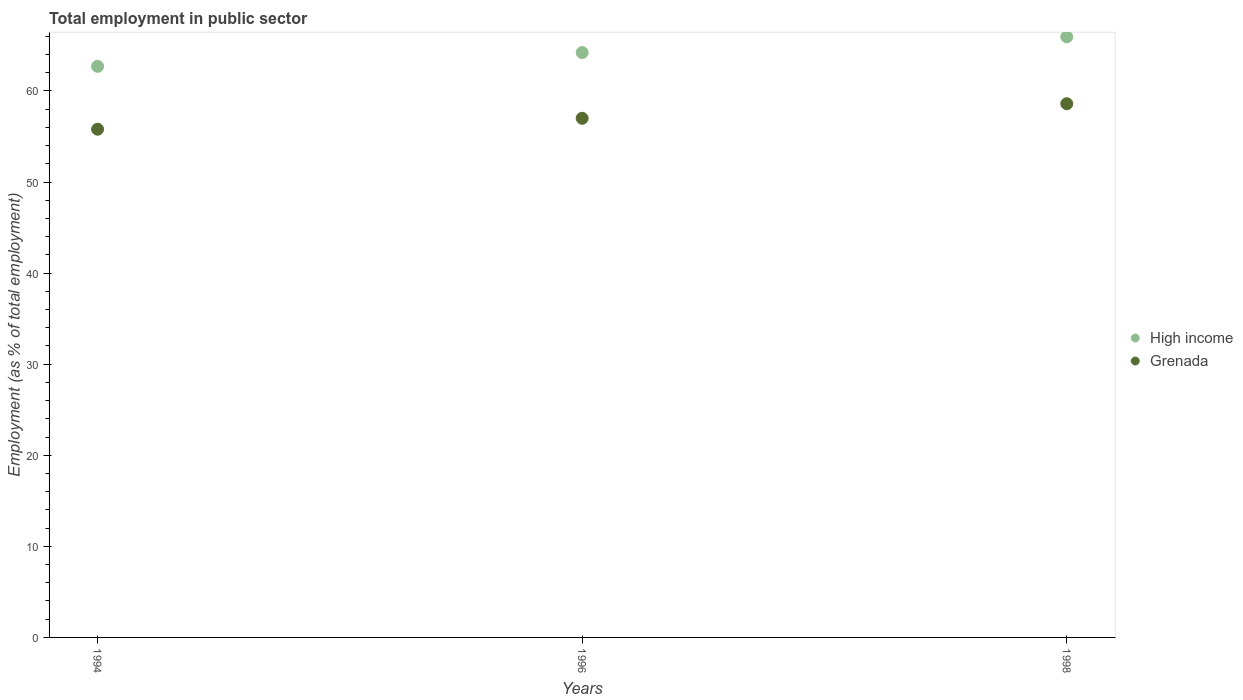How many different coloured dotlines are there?
Provide a short and direct response. 2. Is the number of dotlines equal to the number of legend labels?
Your response must be concise. Yes. What is the employment in public sector in High income in 1996?
Give a very brief answer. 64.22. Across all years, what is the maximum employment in public sector in Grenada?
Give a very brief answer. 58.6. Across all years, what is the minimum employment in public sector in High income?
Provide a succinct answer. 62.71. In which year was the employment in public sector in High income maximum?
Keep it short and to the point. 1998. What is the total employment in public sector in High income in the graph?
Make the answer very short. 192.86. What is the difference between the employment in public sector in High income in 1996 and that in 1998?
Provide a succinct answer. -1.72. What is the difference between the employment in public sector in Grenada in 1998 and the employment in public sector in High income in 1996?
Provide a short and direct response. -5.62. What is the average employment in public sector in Grenada per year?
Your answer should be compact. 57.13. In the year 1998, what is the difference between the employment in public sector in Grenada and employment in public sector in High income?
Offer a very short reply. -7.34. What is the ratio of the employment in public sector in High income in 1994 to that in 1996?
Give a very brief answer. 0.98. Is the employment in public sector in Grenada in 1994 less than that in 1996?
Your response must be concise. Yes. Is the difference between the employment in public sector in Grenada in 1994 and 1996 greater than the difference between the employment in public sector in High income in 1994 and 1996?
Give a very brief answer. Yes. What is the difference between the highest and the second highest employment in public sector in High income?
Give a very brief answer. 1.72. What is the difference between the highest and the lowest employment in public sector in High income?
Ensure brevity in your answer.  3.23. Is the employment in public sector in Grenada strictly greater than the employment in public sector in High income over the years?
Provide a succinct answer. No. How many dotlines are there?
Make the answer very short. 2. How many years are there in the graph?
Your response must be concise. 3. What is the difference between two consecutive major ticks on the Y-axis?
Provide a succinct answer. 10. Does the graph contain any zero values?
Offer a terse response. No. Where does the legend appear in the graph?
Offer a terse response. Center right. How are the legend labels stacked?
Your response must be concise. Vertical. What is the title of the graph?
Your answer should be compact. Total employment in public sector. What is the label or title of the Y-axis?
Make the answer very short. Employment (as % of total employment). What is the Employment (as % of total employment) in High income in 1994?
Your answer should be compact. 62.71. What is the Employment (as % of total employment) of Grenada in 1994?
Your response must be concise. 55.8. What is the Employment (as % of total employment) in High income in 1996?
Offer a terse response. 64.22. What is the Employment (as % of total employment) in Grenada in 1996?
Provide a short and direct response. 57. What is the Employment (as % of total employment) in High income in 1998?
Make the answer very short. 65.94. What is the Employment (as % of total employment) in Grenada in 1998?
Give a very brief answer. 58.6. Across all years, what is the maximum Employment (as % of total employment) in High income?
Keep it short and to the point. 65.94. Across all years, what is the maximum Employment (as % of total employment) in Grenada?
Provide a short and direct response. 58.6. Across all years, what is the minimum Employment (as % of total employment) in High income?
Your response must be concise. 62.71. Across all years, what is the minimum Employment (as % of total employment) in Grenada?
Your answer should be compact. 55.8. What is the total Employment (as % of total employment) in High income in the graph?
Keep it short and to the point. 192.86. What is the total Employment (as % of total employment) in Grenada in the graph?
Make the answer very short. 171.4. What is the difference between the Employment (as % of total employment) of High income in 1994 and that in 1996?
Your answer should be compact. -1.51. What is the difference between the Employment (as % of total employment) in High income in 1994 and that in 1998?
Your answer should be very brief. -3.23. What is the difference between the Employment (as % of total employment) of Grenada in 1994 and that in 1998?
Give a very brief answer. -2.8. What is the difference between the Employment (as % of total employment) of High income in 1996 and that in 1998?
Provide a short and direct response. -1.72. What is the difference between the Employment (as % of total employment) in High income in 1994 and the Employment (as % of total employment) in Grenada in 1996?
Keep it short and to the point. 5.71. What is the difference between the Employment (as % of total employment) in High income in 1994 and the Employment (as % of total employment) in Grenada in 1998?
Ensure brevity in your answer.  4.11. What is the difference between the Employment (as % of total employment) in High income in 1996 and the Employment (as % of total employment) in Grenada in 1998?
Offer a terse response. 5.62. What is the average Employment (as % of total employment) in High income per year?
Ensure brevity in your answer.  64.29. What is the average Employment (as % of total employment) of Grenada per year?
Offer a terse response. 57.13. In the year 1994, what is the difference between the Employment (as % of total employment) in High income and Employment (as % of total employment) in Grenada?
Ensure brevity in your answer.  6.91. In the year 1996, what is the difference between the Employment (as % of total employment) in High income and Employment (as % of total employment) in Grenada?
Offer a terse response. 7.22. In the year 1998, what is the difference between the Employment (as % of total employment) in High income and Employment (as % of total employment) in Grenada?
Your answer should be very brief. 7.34. What is the ratio of the Employment (as % of total employment) in High income in 1994 to that in 1996?
Provide a short and direct response. 0.98. What is the ratio of the Employment (as % of total employment) in Grenada in 1994 to that in 1996?
Ensure brevity in your answer.  0.98. What is the ratio of the Employment (as % of total employment) of High income in 1994 to that in 1998?
Ensure brevity in your answer.  0.95. What is the ratio of the Employment (as % of total employment) in Grenada in 1994 to that in 1998?
Offer a very short reply. 0.95. What is the ratio of the Employment (as % of total employment) of High income in 1996 to that in 1998?
Ensure brevity in your answer.  0.97. What is the ratio of the Employment (as % of total employment) in Grenada in 1996 to that in 1998?
Offer a very short reply. 0.97. What is the difference between the highest and the second highest Employment (as % of total employment) of High income?
Your answer should be compact. 1.72. What is the difference between the highest and the lowest Employment (as % of total employment) of High income?
Give a very brief answer. 3.23. What is the difference between the highest and the lowest Employment (as % of total employment) of Grenada?
Provide a succinct answer. 2.8. 